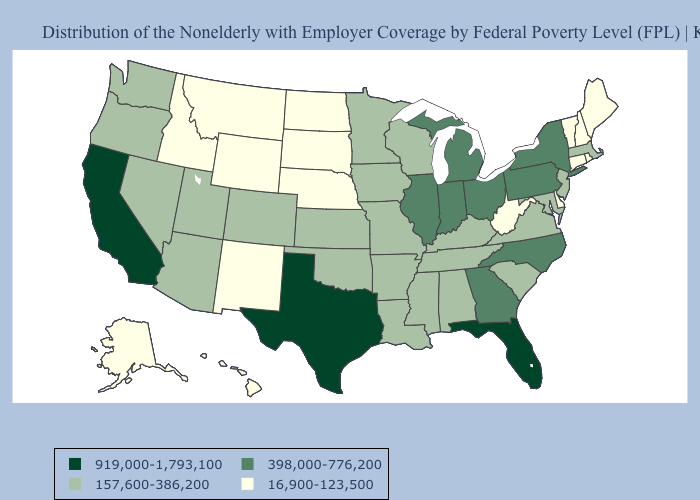What is the value of Arizona?
Quick response, please. 157,600-386,200. What is the highest value in states that border Oklahoma?
Give a very brief answer. 919,000-1,793,100. What is the value of Kansas?
Write a very short answer. 157,600-386,200. What is the lowest value in states that border Connecticut?
Keep it brief. 16,900-123,500. What is the lowest value in the Northeast?
Be succinct. 16,900-123,500. Which states have the highest value in the USA?
Short answer required. California, Florida, Texas. Among the states that border South Carolina , which have the highest value?
Answer briefly. Georgia, North Carolina. What is the value of Wyoming?
Short answer required. 16,900-123,500. Among the states that border Arkansas , which have the lowest value?
Short answer required. Louisiana, Mississippi, Missouri, Oklahoma, Tennessee. Does South Carolina have the highest value in the USA?
Short answer required. No. What is the highest value in the South ?
Short answer required. 919,000-1,793,100. Does the first symbol in the legend represent the smallest category?
Give a very brief answer. No. Does Vermont have a higher value than Oklahoma?
Be succinct. No. Name the states that have a value in the range 398,000-776,200?
Concise answer only. Georgia, Illinois, Indiana, Michigan, New York, North Carolina, Ohio, Pennsylvania. Does New Hampshire have the lowest value in the USA?
Concise answer only. Yes. 